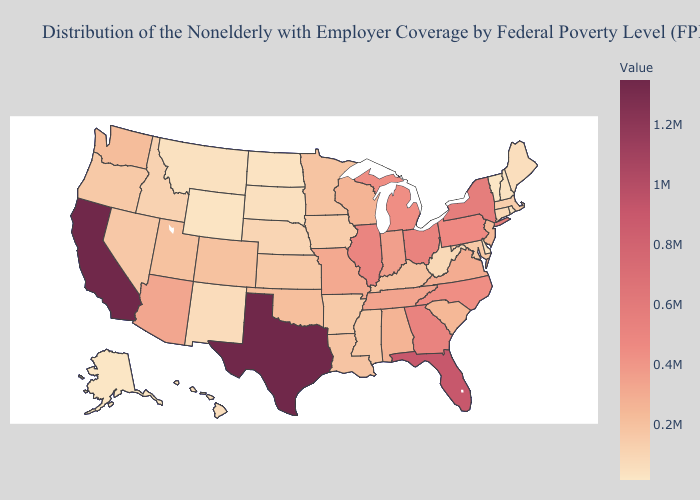Does the map have missing data?
Write a very short answer. No. Which states have the highest value in the USA?
Be succinct. Texas. Does Pennsylvania have the highest value in the Northeast?
Write a very short answer. No. Does Georgia have a lower value than California?
Answer briefly. Yes. Does New York have the lowest value in the Northeast?
Quick response, please. No. Among the states that border Ohio , which have the lowest value?
Write a very short answer. West Virginia. Does New York have the highest value in the Northeast?
Answer briefly. Yes. 